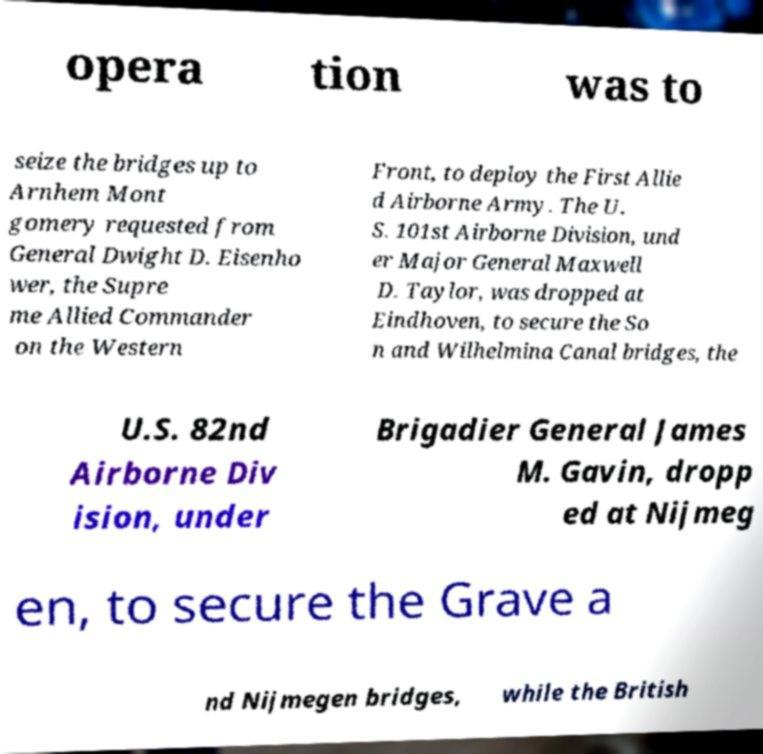I need the written content from this picture converted into text. Can you do that? opera tion was to seize the bridges up to Arnhem Mont gomery requested from General Dwight D. Eisenho wer, the Supre me Allied Commander on the Western Front, to deploy the First Allie d Airborne Army. The U. S. 101st Airborne Division, und er Major General Maxwell D. Taylor, was dropped at Eindhoven, to secure the So n and Wilhelmina Canal bridges, the U.S. 82nd Airborne Div ision, under Brigadier General James M. Gavin, dropp ed at Nijmeg en, to secure the Grave a nd Nijmegen bridges, while the British 